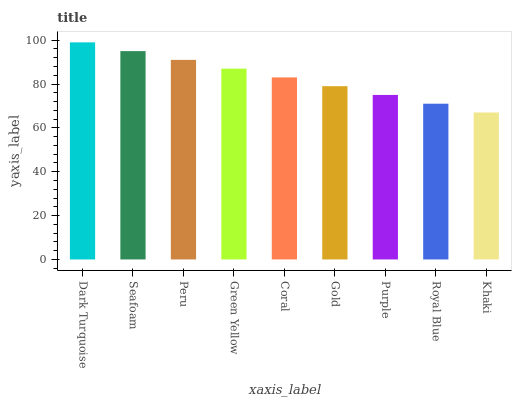Is Khaki the minimum?
Answer yes or no. Yes. Is Dark Turquoise the maximum?
Answer yes or no. Yes. Is Seafoam the minimum?
Answer yes or no. No. Is Seafoam the maximum?
Answer yes or no. No. Is Dark Turquoise greater than Seafoam?
Answer yes or no. Yes. Is Seafoam less than Dark Turquoise?
Answer yes or no. Yes. Is Seafoam greater than Dark Turquoise?
Answer yes or no. No. Is Dark Turquoise less than Seafoam?
Answer yes or no. No. Is Coral the high median?
Answer yes or no. Yes. Is Coral the low median?
Answer yes or no. Yes. Is Green Yellow the high median?
Answer yes or no. No. Is Royal Blue the low median?
Answer yes or no. No. 